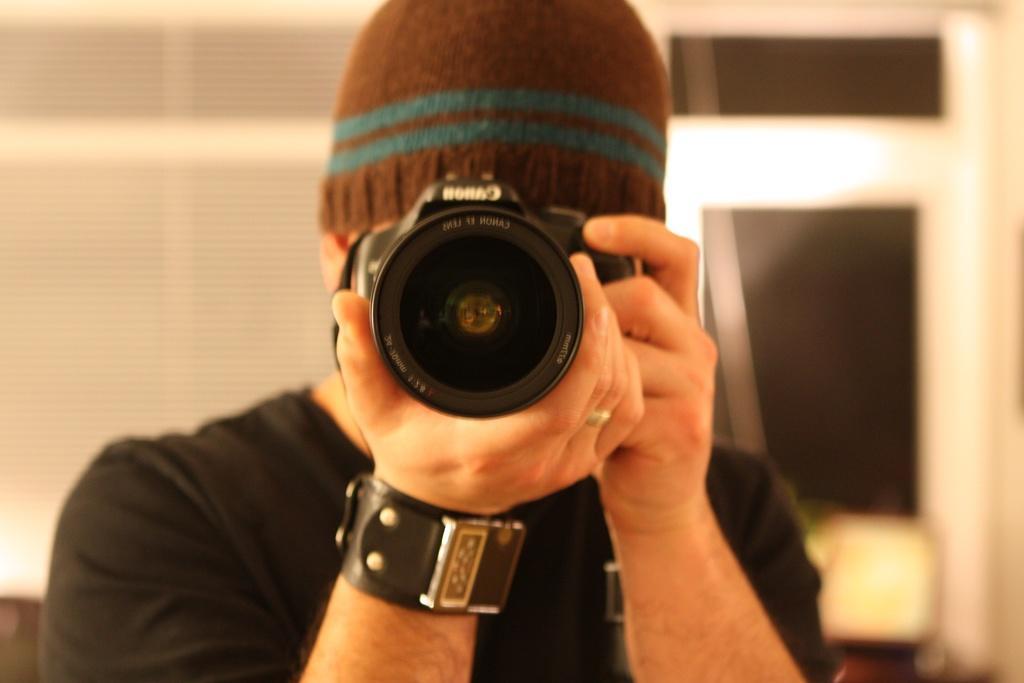Please provide a concise description of this image. In the center of the image we can see a man standing and holding a camera in his hand. In the background there is a door. 